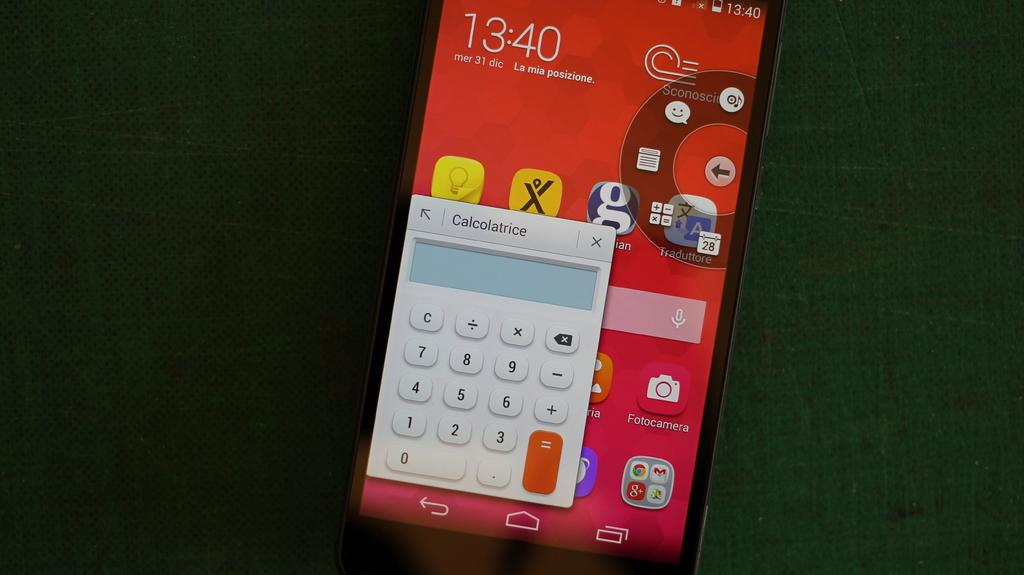<image>
Write a terse but informative summary of the picture. An electronic device showing the time as 13:40/. 